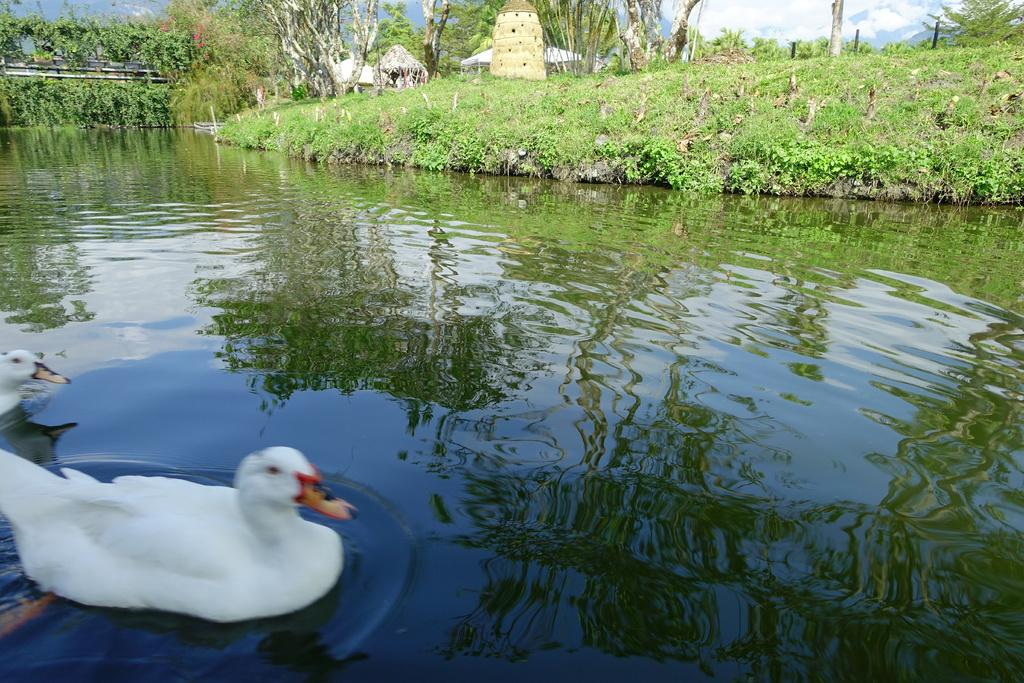What type of animals can be seen in the image? Birds can be seen in the image. What is the primary element in which the birds are situated? The birds are situated in water. What type of vegetation is present in the image? There are plants and trees in the image. What type of structures can be seen in the image? There are huts in the image. What is visible in the background of the image? The sky is visible in the background of the image, and clouds are present in the sky. What type of bean is being used as a support for the arch in the image? There is no arch or bean present in the image. 